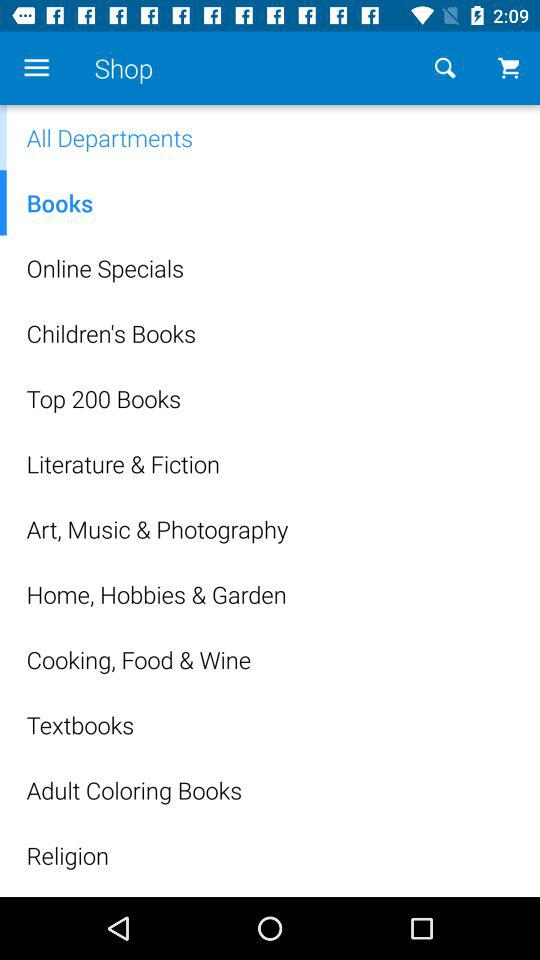What is the application name?
When the provided information is insufficient, respond with <no answer>. <no answer> 